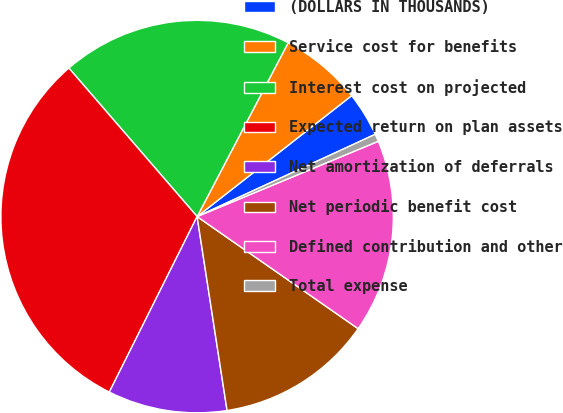<chart> <loc_0><loc_0><loc_500><loc_500><pie_chart><fcel>(DOLLARS IN THOUSANDS)<fcel>Service cost for benefits<fcel>Interest cost on projected<fcel>Expected return on plan assets<fcel>Net amortization of deferrals<fcel>Net periodic benefit cost<fcel>Defined contribution and other<fcel>Total expense<nl><fcel>3.68%<fcel>6.75%<fcel>19.02%<fcel>31.28%<fcel>9.82%<fcel>12.88%<fcel>15.95%<fcel>0.62%<nl></chart> 